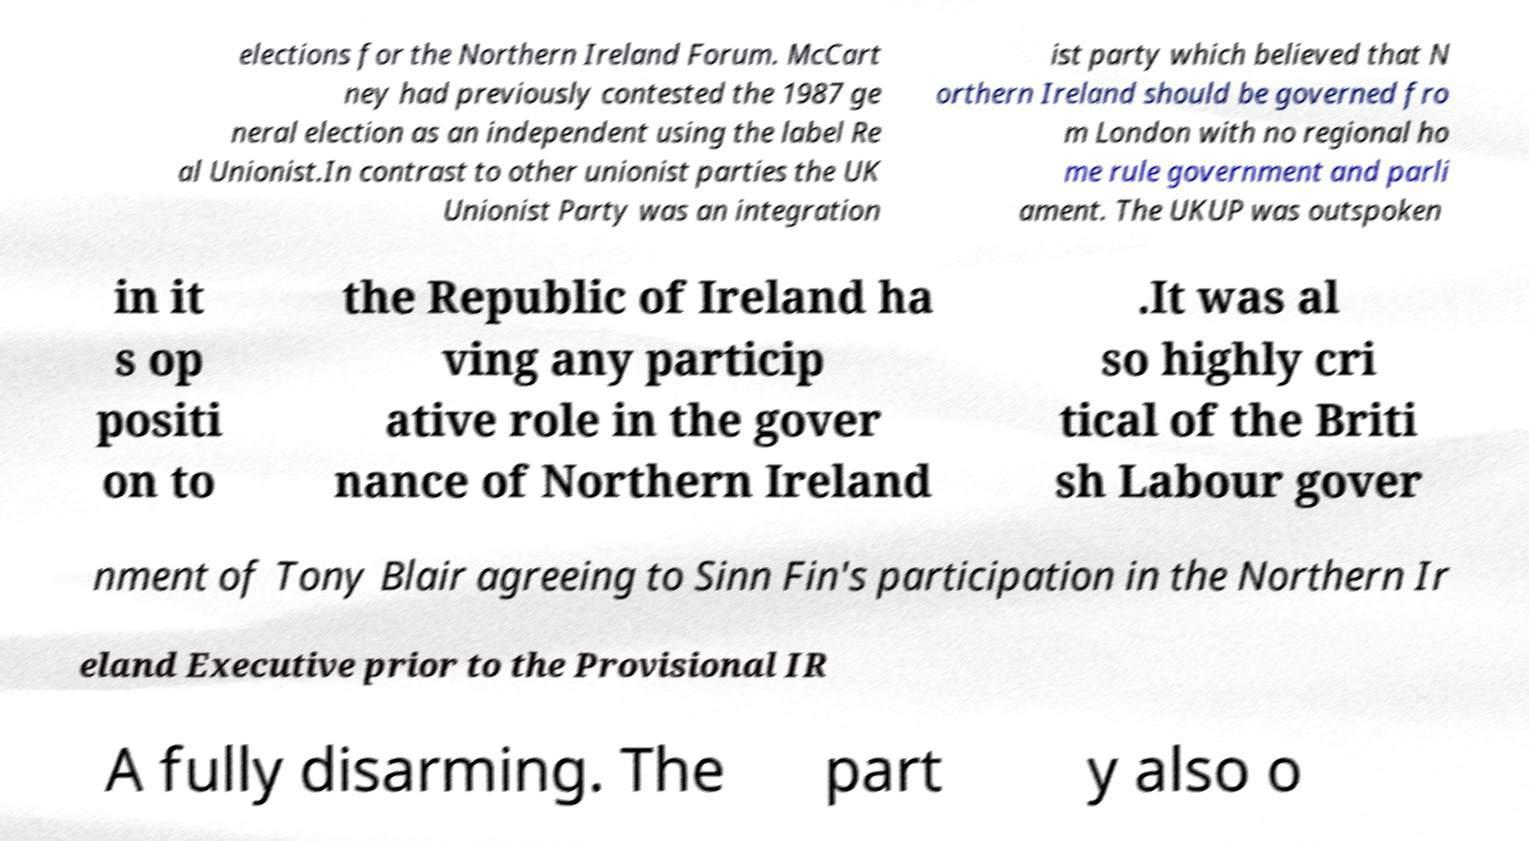Could you extract and type out the text from this image? elections for the Northern Ireland Forum. McCart ney had previously contested the 1987 ge neral election as an independent using the label Re al Unionist.In contrast to other unionist parties the UK Unionist Party was an integration ist party which believed that N orthern Ireland should be governed fro m London with no regional ho me rule government and parli ament. The UKUP was outspoken in it s op positi on to the Republic of Ireland ha ving any particip ative role in the gover nance of Northern Ireland .It was al so highly cri tical of the Briti sh Labour gover nment of Tony Blair agreeing to Sinn Fin's participation in the Northern Ir eland Executive prior to the Provisional IR A fully disarming. The part y also o 